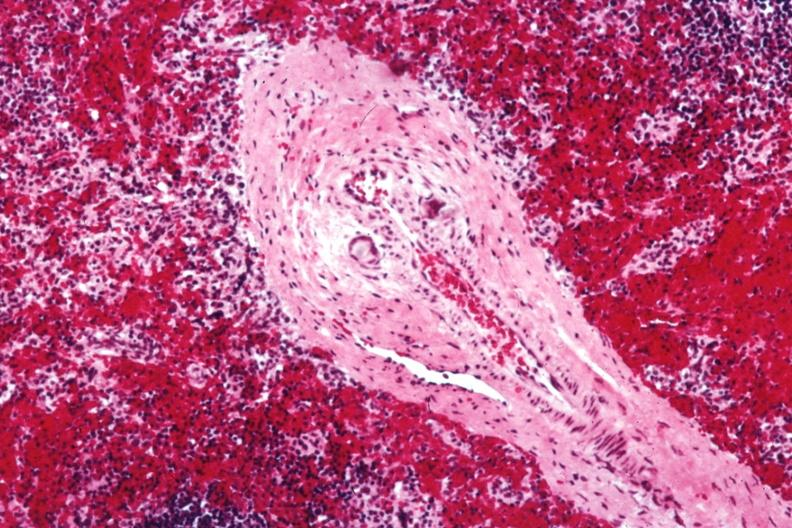s postoperative cardiac surgery thought to be silicon?
Answer the question using a single word or phrase. Yes 